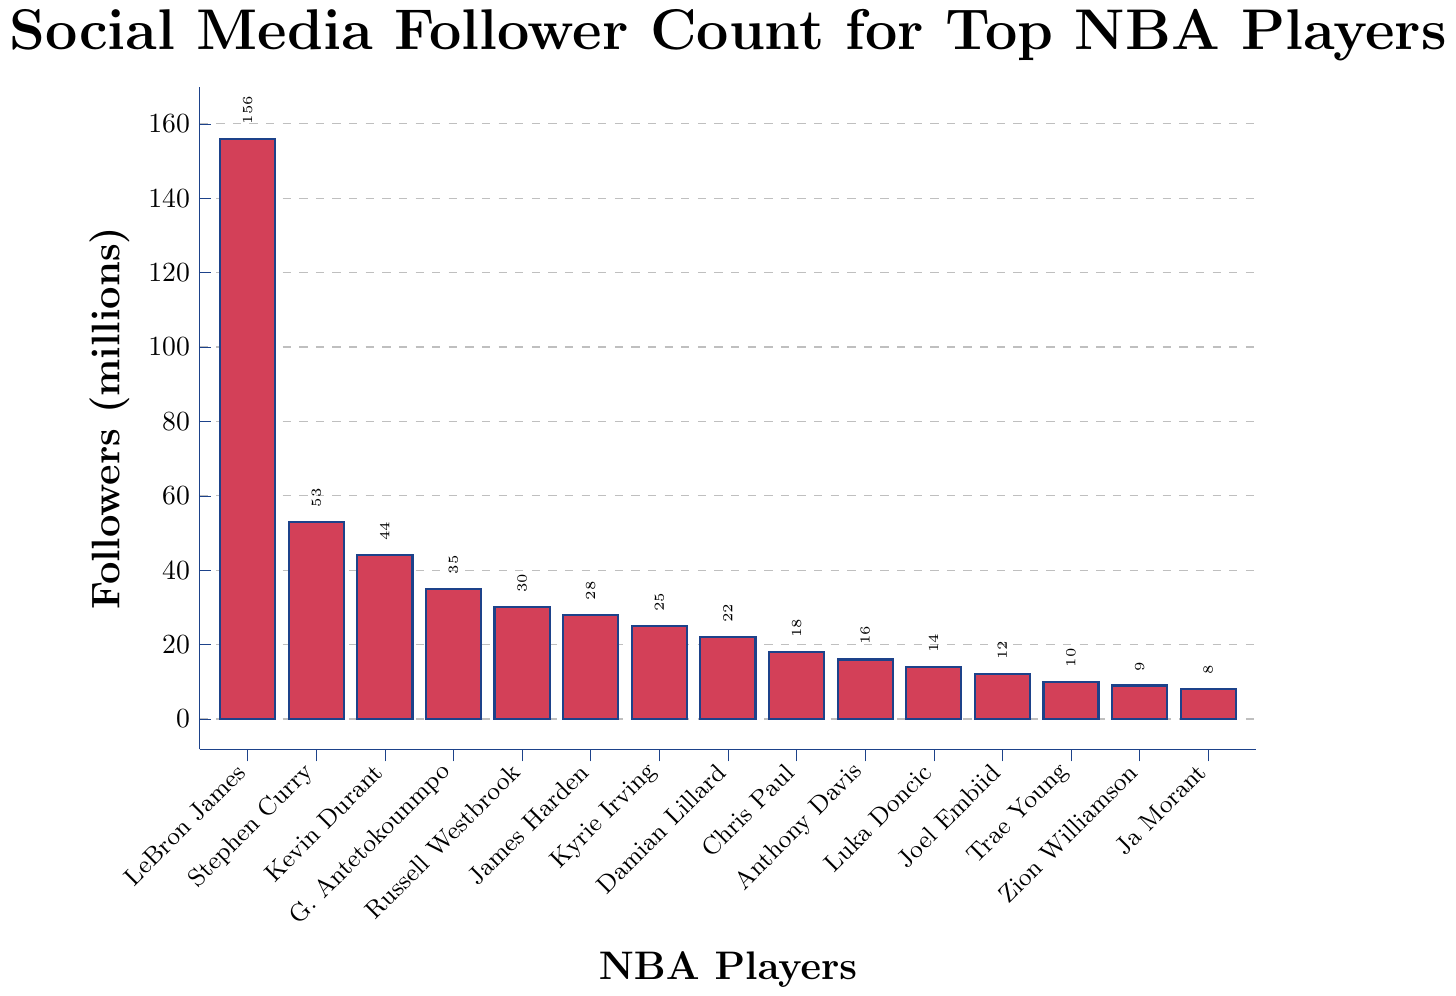How many players have more than 50 million followers? Identify the players with follower counts greater than 50 million: LeBron James (156 million) and Stephen Curry (53 million). Count the players: 2
Answer: 2 Who has more followers, Kevin Durant or Giannis Antetokounmpo? Compare the follower counts of Kevin Durant (44 million) and Giannis Antetokounmpo (35 million). Kevin Durant has more followers.
Answer: Kevin Durant What is the difference in follower count between the player with the most followers and the player with the least followers? Calculate the difference: LeBron James (156 million) - Ja Morant (8 million) = 148 million
Answer: 148 million What is the total follower count of the top 3 players combined? Add the follower counts of LeBron James (156 million), Stephen Curry (53 million), and Kevin Durant (44 million): 156 + 53 + 44 = 253 million
Answer: 253 million How many players have fewer than 20 million followers? Identify the players with fewer than 20 million followers: Chris Paul, Anthony Davis, Luka Doncic, Joel Embiid, Trae Young, Zion Williamson, and Ja Morant. Count them: 7
Answer: 7 Is Stephen Curry's follower count less than half of LeBron James'? Calculate half of LeBron James' followers: 156 / 2 = 78 million. Compare Stephen Curry's count (53 million) with 78 million: Yes, it's less.
Answer: Yes What is the average follower count of the entire list of players? Calculate the sum of all follower counts: 156 + 53 + 44 + 35 + 30 + 28 + 25 + 22 + 18 + 16 + 14 + 12 + 10 + 9 + 8 = 480 million. Divide by the number of players (15): 480 / 15 ≈ 32 million
Answer: 32 million Which players have a follower count of exactly 10 million or less? Identify players with 10 million or fewer followers: Trae Young (10 million), Zion Williamson (9 million), Ja Morant (8 million).
Answer: Trae Young, Zion Williamson, Ja Morant What is the median follower count of the players? Arrange the follower counts in ascending order: 8, 9, 10, 12, 14, 16, 18, 22, 25, 28, 30, 35, 44, 53, 156. The median is the middle value, which is 22 million (Damian Lillard).
Answer: 22 million Do more players have follower counts above or below the median? Identify the median follower count (22 million) and count players above and below it. Below: 8, 9, 10, 12, 14, 16, 18 (7 players). Above: 25, 28, 30, 35, 44, 53, 156 (7 players). The count is equal.
Answer: Equal 